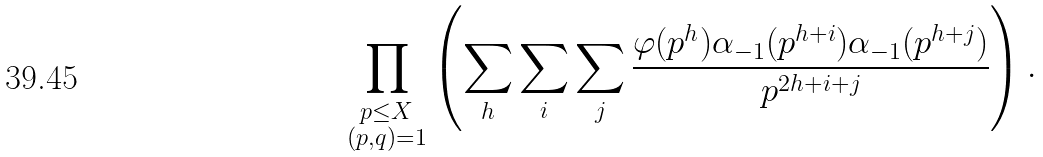Convert formula to latex. <formula><loc_0><loc_0><loc_500><loc_500>\prod _ { \substack { p \leq X \\ ( p , q ) = 1 } } \left ( \sum _ { h } \sum _ { i } \sum _ { j } \frac { \varphi ( p ^ { h } ) \alpha _ { - 1 } ( p ^ { h + i } ) \alpha _ { - 1 } ( p ^ { h + j } ) } { p ^ { 2 h + i + j } } \right ) .</formula> 